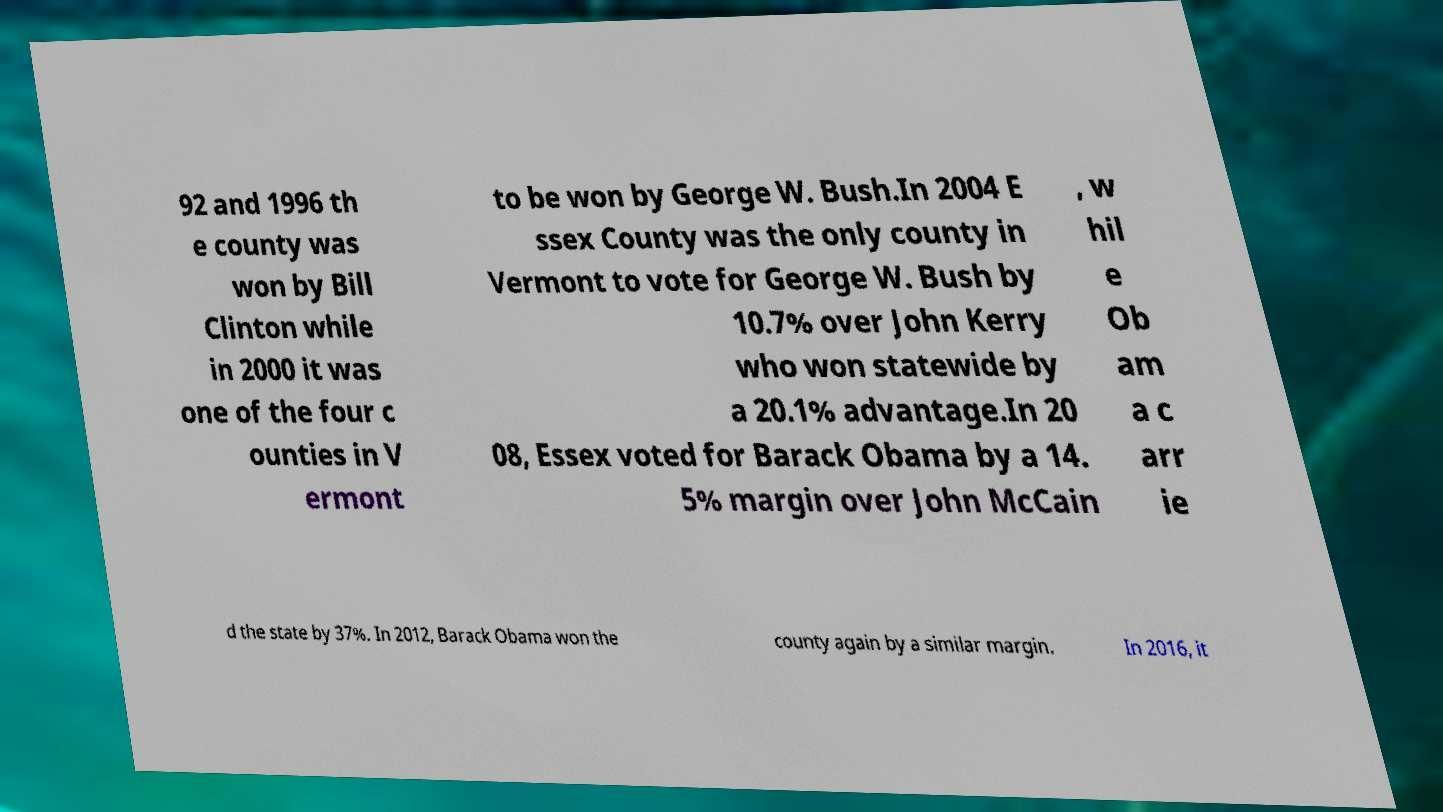There's text embedded in this image that I need extracted. Can you transcribe it verbatim? 92 and 1996 th e county was won by Bill Clinton while in 2000 it was one of the four c ounties in V ermont to be won by George W. Bush.In 2004 E ssex County was the only county in Vermont to vote for George W. Bush by 10.7% over John Kerry who won statewide by a 20.1% advantage.In 20 08, Essex voted for Barack Obama by a 14. 5% margin over John McCain , w hil e Ob am a c arr ie d the state by 37%. In 2012, Barack Obama won the county again by a similar margin. In 2016, it 